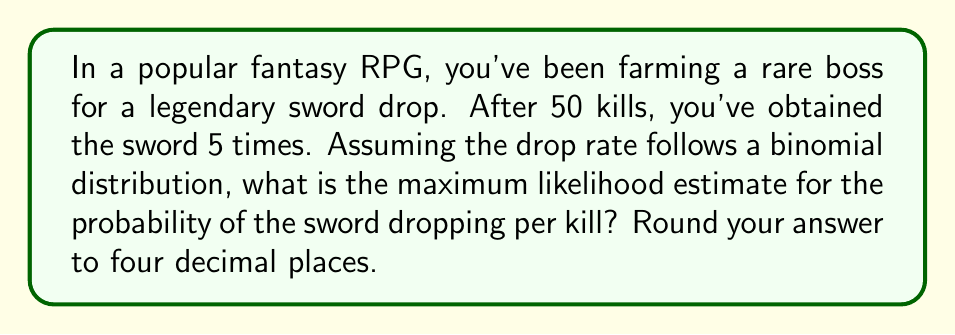Can you answer this question? Let's approach this step-by-step:

1) In this scenario, we're dealing with a binomial distribution where each kill is an independent trial, and we're interested in the probability of success (sword drop) for each trial.

2) The maximum likelihood estimate (MLE) for the probability parameter $p$ in a binomial distribution is given by:

   $$\hat{p} = \frac{x}{n}$$

   where $x$ is the number of successes and $n$ is the total number of trials.

3) In our case:
   $x = 5$ (number of sword drops)
   $n = 50$ (total number of kills)

4) Plugging these values into our formula:

   $$\hat{p} = \frac{5}{50} = 0.1$$

5) Therefore, the maximum likelihood estimate for the probability of the sword dropping per kill is 0.1 or 10%.

6) Rounding to four decimal places: 0.1000

This approach aligns with a gamer's perspective of analyzing drop rates based on observed data, which is often used to infer game mechanics and probabilities.
Answer: 0.1000 